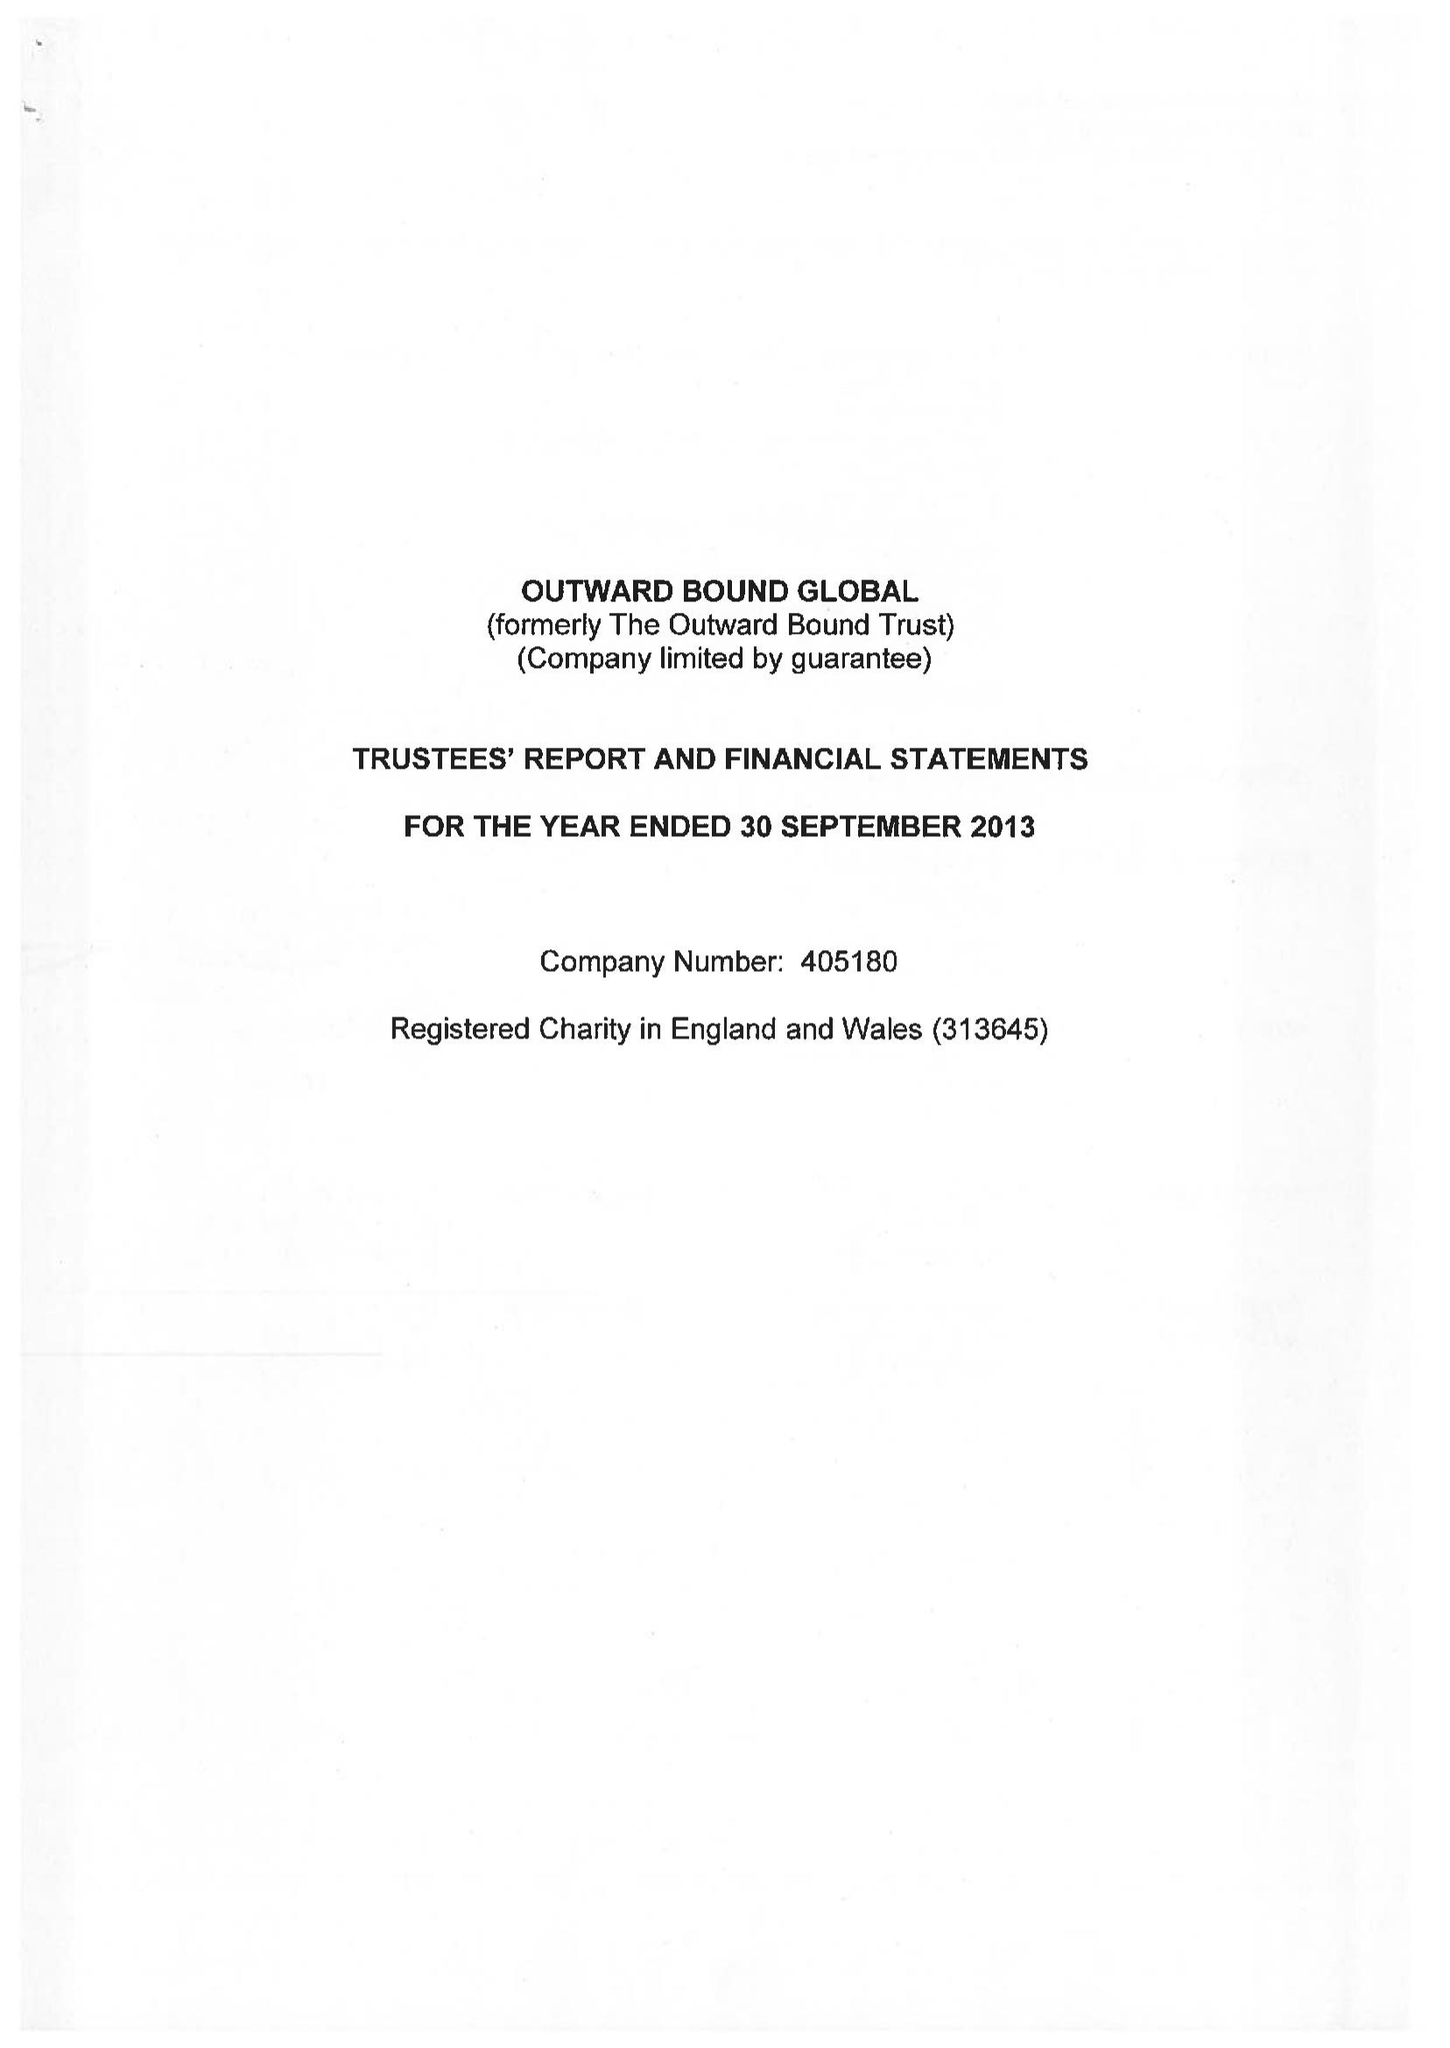What is the value for the report_date?
Answer the question using a single word or phrase. 2013-09-30 